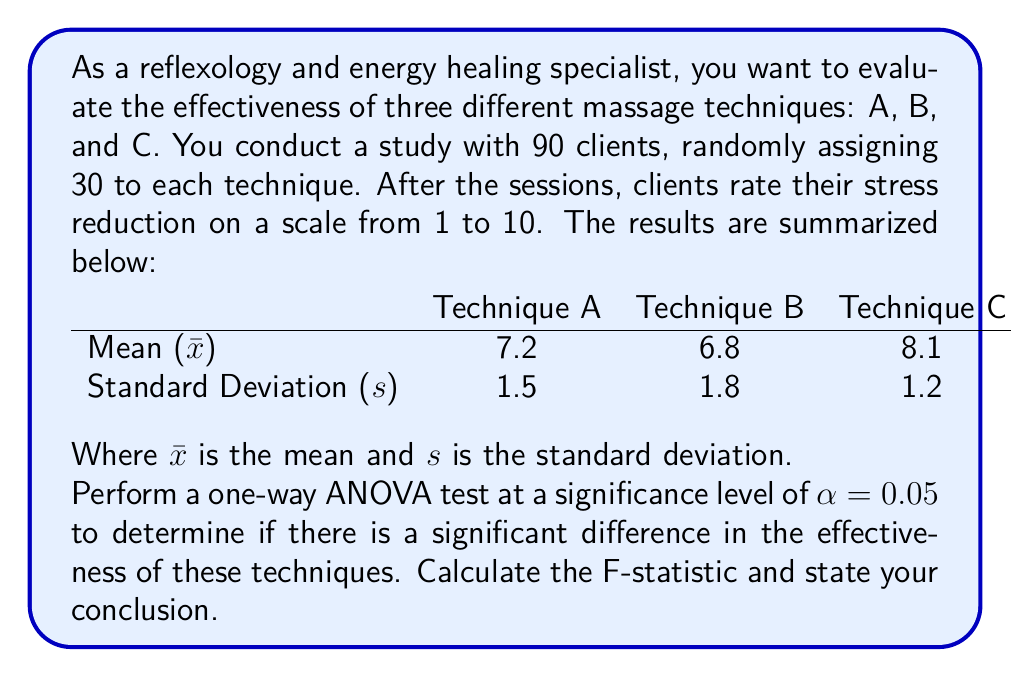Solve this math problem. To perform a one-way ANOVA test, we need to follow these steps:

1) Calculate the Sum of Squares Between (SSB):
   $$SSB = \sum_{i=1}^k n_i(\bar{x}_i - \bar{x})^2$$
   where $k$ is the number of groups, $n_i$ is the sample size of each group, $\bar{x}_i$ is the mean of each group, and $\bar{x}$ is the grand mean.

2) Calculate the Sum of Squares Within (SSW):
   $$SSW = \sum_{i=1}^k (n_i - 1)s_i^2$$
   where $s_i$ is the standard deviation of each group.

3) Calculate the degrees of freedom:
   $df_{between} = k - 1$
   $df_{within} = N - k$
   where $N$ is the total sample size.

4) Calculate the Mean Square Between (MSB) and Mean Square Within (MSW):
   $$MSB = \frac{SSB}{df_{between}}$$
   $$MSW = \frac{SSW}{df_{within}}$$

5) Calculate the F-statistic:
   $$F = \frac{MSB}{MSW}$$

Let's apply these steps:

1) First, calculate the grand mean:
   $$\bar{x} = \frac{7.2 + 6.8 + 8.1}{3} = 7.37$$

   Now calculate SSB:
   $$SSB = 30(7.2 - 7.37)^2 + 30(6.8 - 7.37)^2 + 30(8.1 - 7.37)^2 = 31.86$$

2) Calculate SSW:
   $$SSW = 29(1.5^2) + 29(1.8^2) + 29(1.2^2) = 185.85$$

3) Degrees of freedom:
   $df_{between} = 3 - 1 = 2$
   $df_{within} = 90 - 3 = 87$

4) Calculate MSB and MSW:
   $$MSB = \frac{31.86}{2} = 15.93$$
   $$MSW = \frac{185.85}{87} = 2.14$$

5) Calculate F-statistic:
   $$F = \frac{15.93}{2.14} = 7.45$$

The critical F-value for $\alpha = 0.05$, $df_{between} = 2$, and $df_{within} = 87$ is approximately 3.10.

Since our calculated F-statistic (7.45) is greater than the critical F-value (3.10), we reject the null hypothesis. This means there is a significant difference in the effectiveness of these massage techniques at the 0.05 significance level.
Answer: F-statistic = 7.45; Significant difference exists 